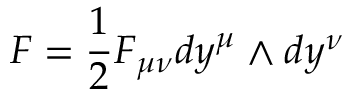<formula> <loc_0><loc_0><loc_500><loc_500>F = { \frac { 1 } { 2 } } F _ { \mu \nu } d y ^ { \mu } \wedge d y ^ { \nu }</formula> 